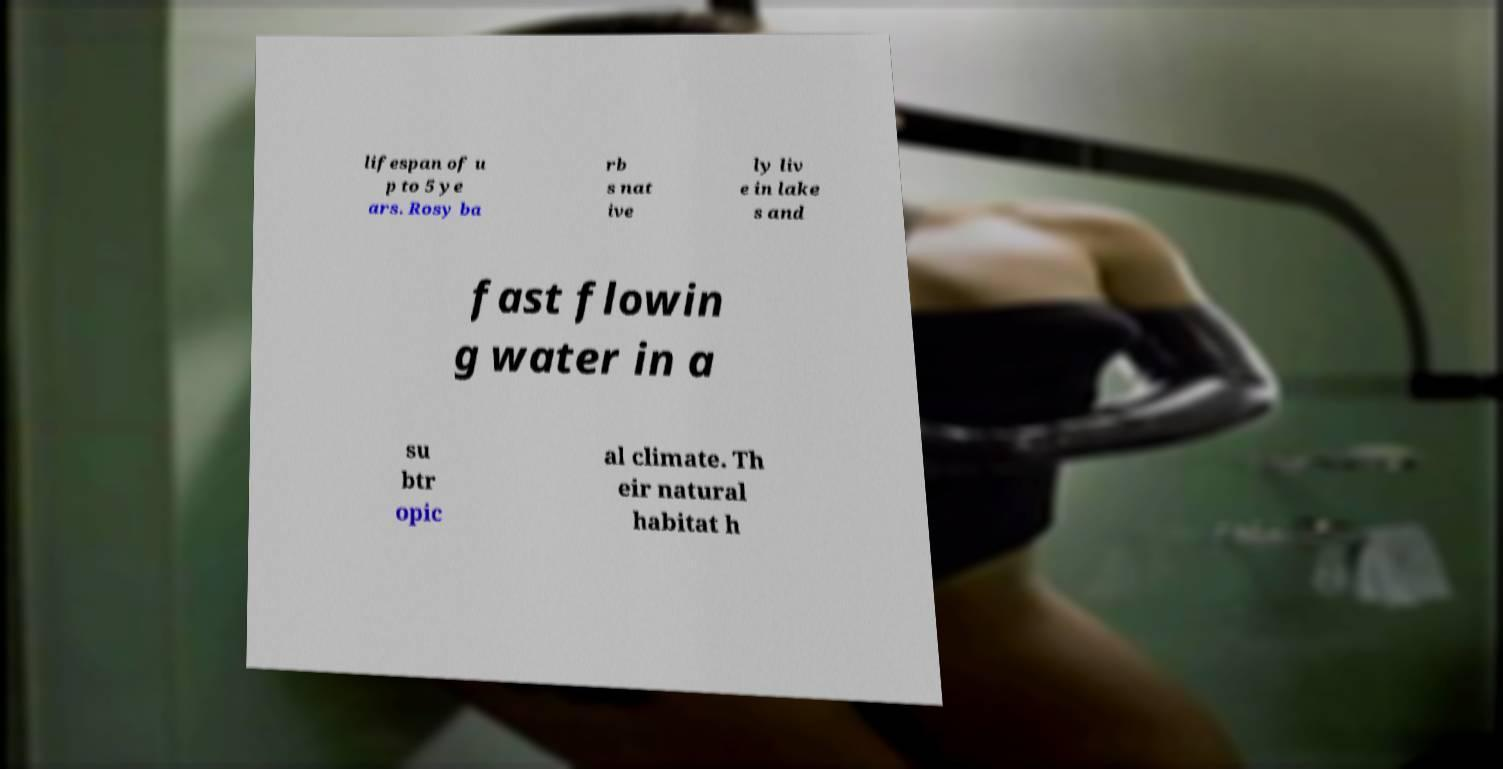For documentation purposes, I need the text within this image transcribed. Could you provide that? lifespan of u p to 5 ye ars. Rosy ba rb s nat ive ly liv e in lake s and fast flowin g water in a su btr opic al climate. Th eir natural habitat h 